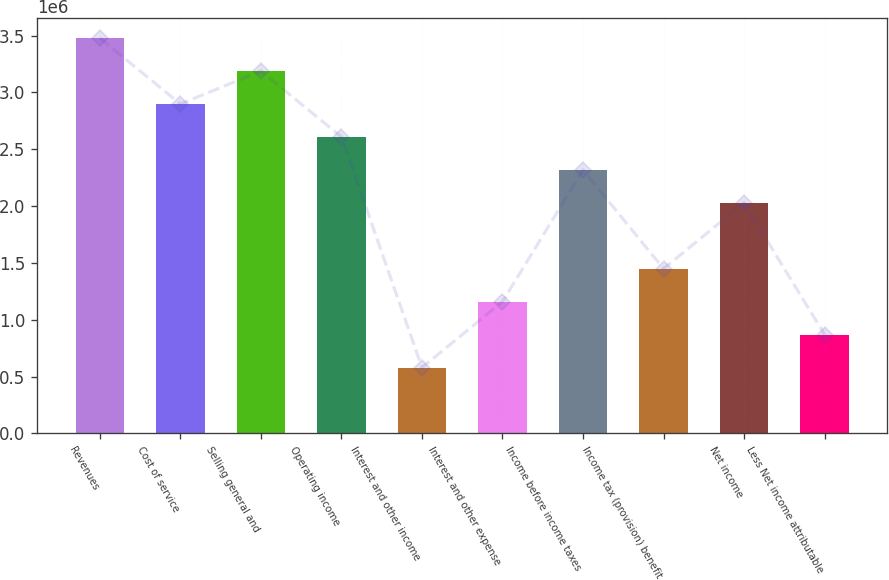Convert chart to OTSL. <chart><loc_0><loc_0><loc_500><loc_500><bar_chart><fcel>Revenues<fcel>Cost of service<fcel>Selling general and<fcel>Operating income<fcel>Interest and other income<fcel>Interest and other expense<fcel>Income before income taxes<fcel>Income tax (provision) benefit<fcel>Net income<fcel>Less Net income attributable<nl><fcel>3.47778e+06<fcel>2.89815e+06<fcel>3.18796e+06<fcel>2.60834e+06<fcel>579632<fcel>1.15926e+06<fcel>2.31852e+06<fcel>1.44908e+06<fcel>2.02871e+06<fcel>869446<nl></chart> 